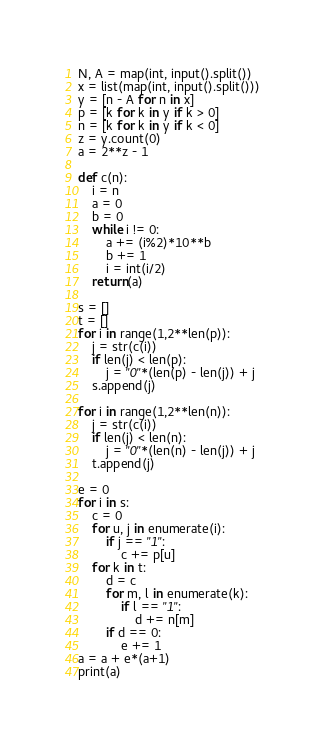<code> <loc_0><loc_0><loc_500><loc_500><_Python_>N, A = map(int, input().split())
x = list(map(int, input().split()))
y = [n - A for n in x]
p = [k for k in y if k > 0]
n = [k for k in y if k < 0]
z = y.count(0)
a = 2**z - 1

def c(n):
	i = n
	a = 0
	b = 0
	while i != 0:
		a += (i%2)*10**b
		b += 1
		i = int(i/2)
	return(a)

s = []
t = []
for i in range(1,2**len(p)):
	j = str(c(i))
	if len(j) < len(p):
		j = "0"*(len(p) - len(j)) + j
	s.append(j)

for i in range(1,2**len(n)):
	j = str(c(i))
	if len(j) < len(n):
		j = "0"*(len(n) - len(j)) + j
	t.append(j)

e = 0
for i in s:
	c = 0
	for u, j in enumerate(i):
		if j == "1":
			c += p[u]
	for k in t:
		d = c
		for m, l in enumerate(k):
			if l == "1":
				d += n[m]
		if d == 0:
			e += 1
a = a + e*(a+1)
print(a)
</code> 